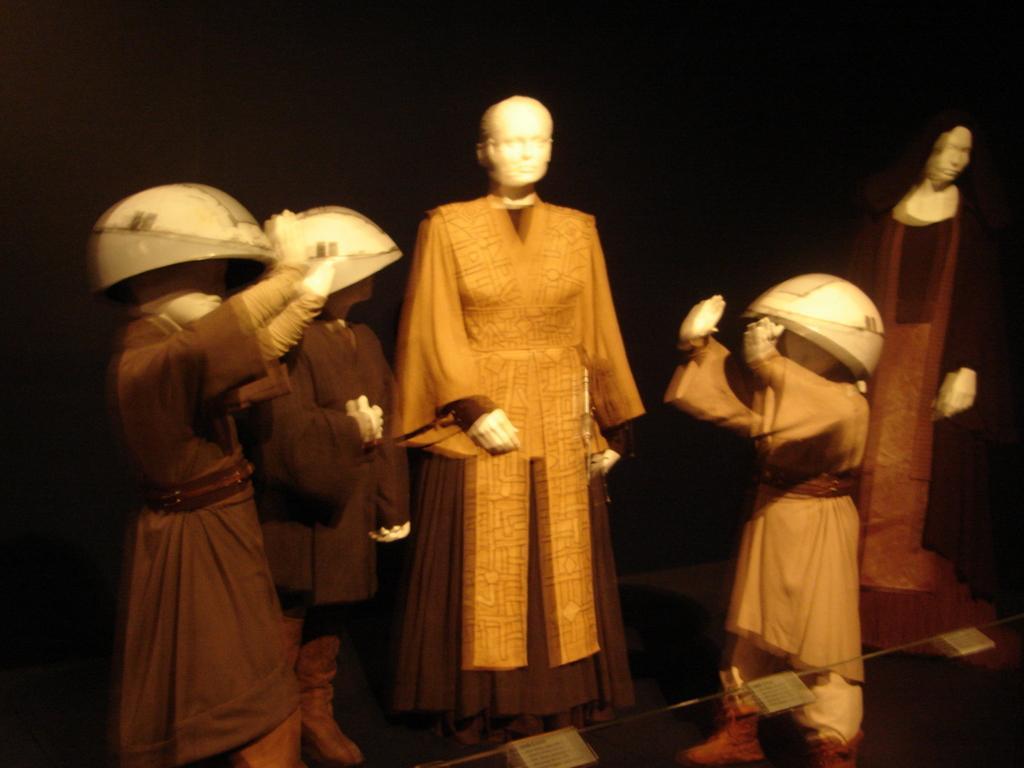Please provide a concise description of this image. In this image I can see group of mannequins standing. In front I can see the dress in brown color and I can see the dark background. 